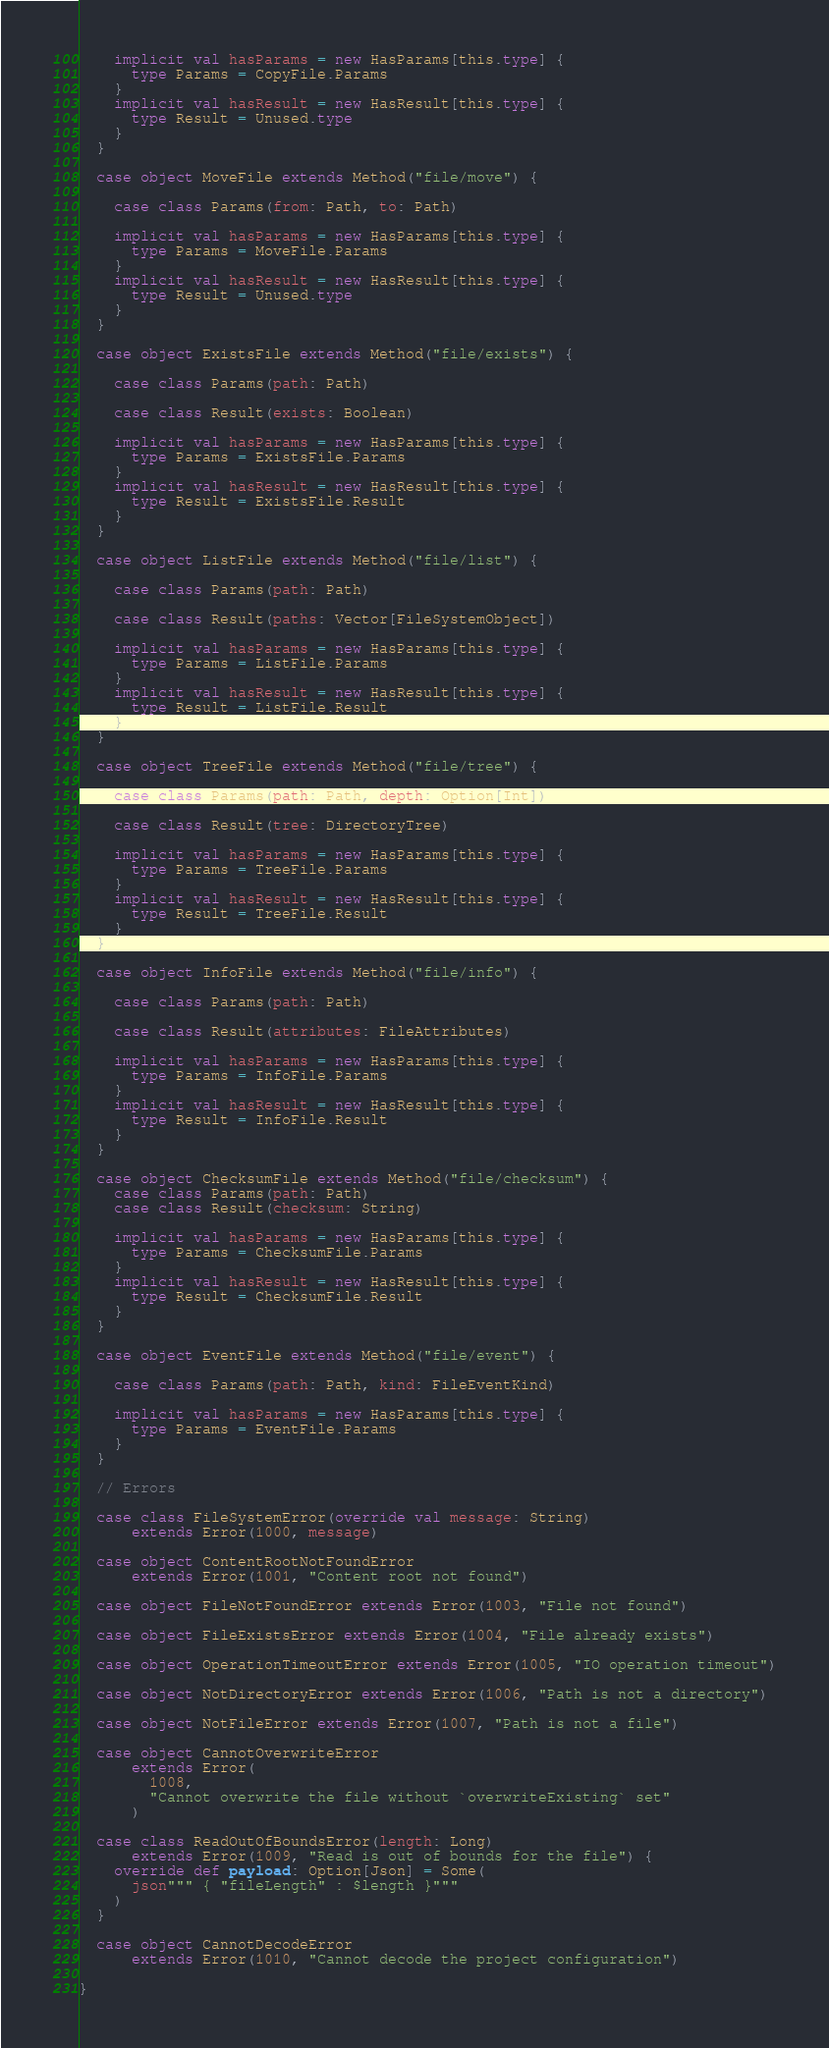<code> <loc_0><loc_0><loc_500><loc_500><_Scala_>
    implicit val hasParams = new HasParams[this.type] {
      type Params = CopyFile.Params
    }
    implicit val hasResult = new HasResult[this.type] {
      type Result = Unused.type
    }
  }

  case object MoveFile extends Method("file/move") {

    case class Params(from: Path, to: Path)

    implicit val hasParams = new HasParams[this.type] {
      type Params = MoveFile.Params
    }
    implicit val hasResult = new HasResult[this.type] {
      type Result = Unused.type
    }
  }

  case object ExistsFile extends Method("file/exists") {

    case class Params(path: Path)

    case class Result(exists: Boolean)

    implicit val hasParams = new HasParams[this.type] {
      type Params = ExistsFile.Params
    }
    implicit val hasResult = new HasResult[this.type] {
      type Result = ExistsFile.Result
    }
  }

  case object ListFile extends Method("file/list") {

    case class Params(path: Path)

    case class Result(paths: Vector[FileSystemObject])

    implicit val hasParams = new HasParams[this.type] {
      type Params = ListFile.Params
    }
    implicit val hasResult = new HasResult[this.type] {
      type Result = ListFile.Result
    }
  }

  case object TreeFile extends Method("file/tree") {

    case class Params(path: Path, depth: Option[Int])

    case class Result(tree: DirectoryTree)

    implicit val hasParams = new HasParams[this.type] {
      type Params = TreeFile.Params
    }
    implicit val hasResult = new HasResult[this.type] {
      type Result = TreeFile.Result
    }
  }

  case object InfoFile extends Method("file/info") {

    case class Params(path: Path)

    case class Result(attributes: FileAttributes)

    implicit val hasParams = new HasParams[this.type] {
      type Params = InfoFile.Params
    }
    implicit val hasResult = new HasResult[this.type] {
      type Result = InfoFile.Result
    }
  }

  case object ChecksumFile extends Method("file/checksum") {
    case class Params(path: Path)
    case class Result(checksum: String)

    implicit val hasParams = new HasParams[this.type] {
      type Params = ChecksumFile.Params
    }
    implicit val hasResult = new HasResult[this.type] {
      type Result = ChecksumFile.Result
    }
  }

  case object EventFile extends Method("file/event") {

    case class Params(path: Path, kind: FileEventKind)

    implicit val hasParams = new HasParams[this.type] {
      type Params = EventFile.Params
    }
  }

  // Errors

  case class FileSystemError(override val message: String)
      extends Error(1000, message)

  case object ContentRootNotFoundError
      extends Error(1001, "Content root not found")

  case object FileNotFoundError extends Error(1003, "File not found")

  case object FileExistsError extends Error(1004, "File already exists")

  case object OperationTimeoutError extends Error(1005, "IO operation timeout")

  case object NotDirectoryError extends Error(1006, "Path is not a directory")

  case object NotFileError extends Error(1007, "Path is not a file")

  case object CannotOverwriteError
      extends Error(
        1008,
        "Cannot overwrite the file without `overwriteExisting` set"
      )

  case class ReadOutOfBoundsError(length: Long)
      extends Error(1009, "Read is out of bounds for the file") {
    override def payload: Option[Json] = Some(
      json""" { "fileLength" : $length }"""
    )
  }

  case object CannotDecodeError
      extends Error(1010, "Cannot decode the project configuration")

}
</code> 